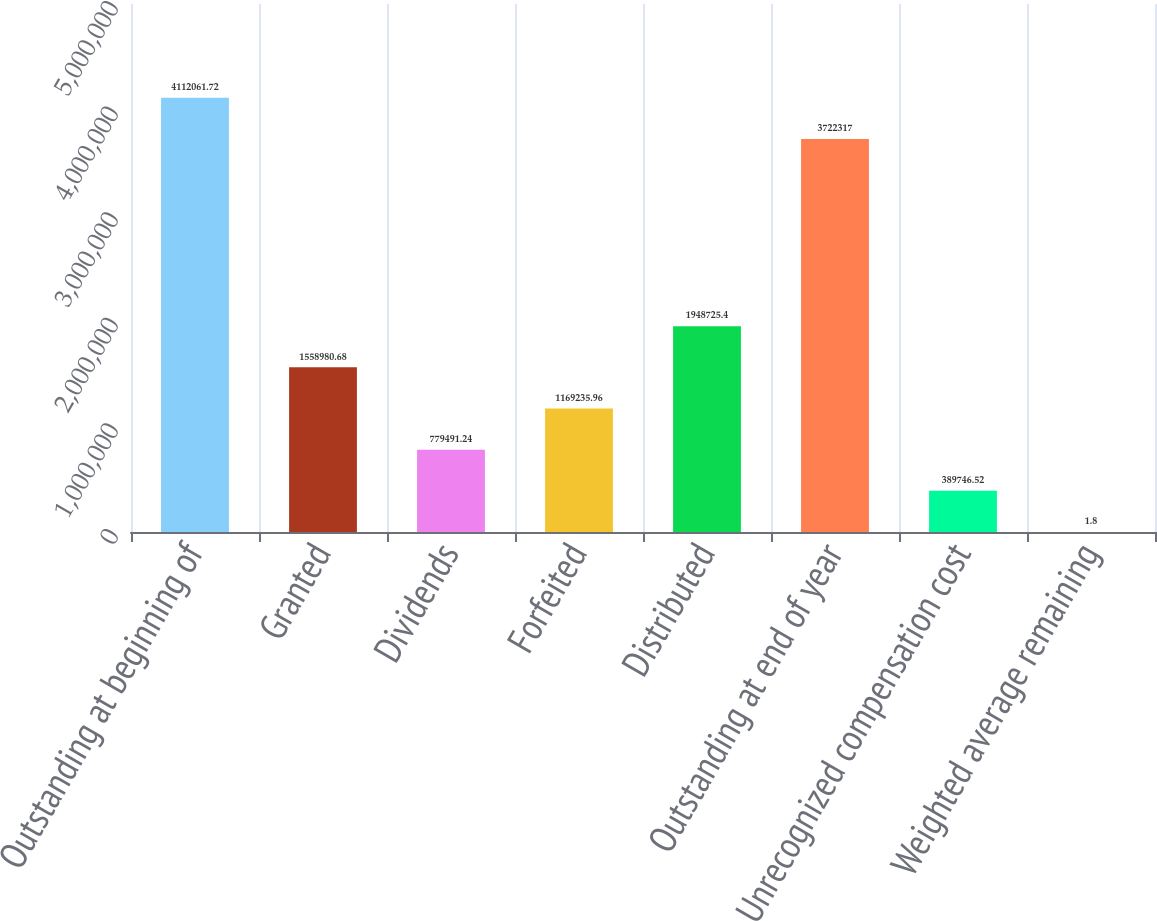Convert chart to OTSL. <chart><loc_0><loc_0><loc_500><loc_500><bar_chart><fcel>Outstanding at beginning of<fcel>Granted<fcel>Dividends<fcel>Forfeited<fcel>Distributed<fcel>Outstanding at end of year<fcel>Unrecognized compensation cost<fcel>Weighted average remaining<nl><fcel>4.11206e+06<fcel>1.55898e+06<fcel>779491<fcel>1.16924e+06<fcel>1.94873e+06<fcel>3.72232e+06<fcel>389747<fcel>1.8<nl></chart> 